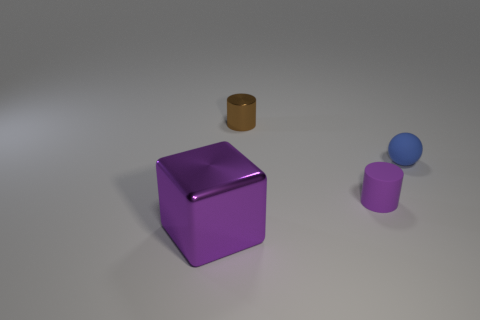What materials do the objects in the image appear to be made of? The objects in the image give the impression of being made from different materials. The large purple cube seems to have a shiny, perhaps plastic-like surface, which is smooth and reflective. The small brown object appears to be matte, possibly resembling a material like cork or wood. The remaining purple and blue objects might be rubber or matte plastic given their less reflective surfaces. 